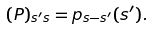<formula> <loc_0><loc_0><loc_500><loc_500>( P ) _ { s ^ { \prime } s } = p _ { s - s ^ { \prime } } ( s ^ { \prime } ) .</formula> 